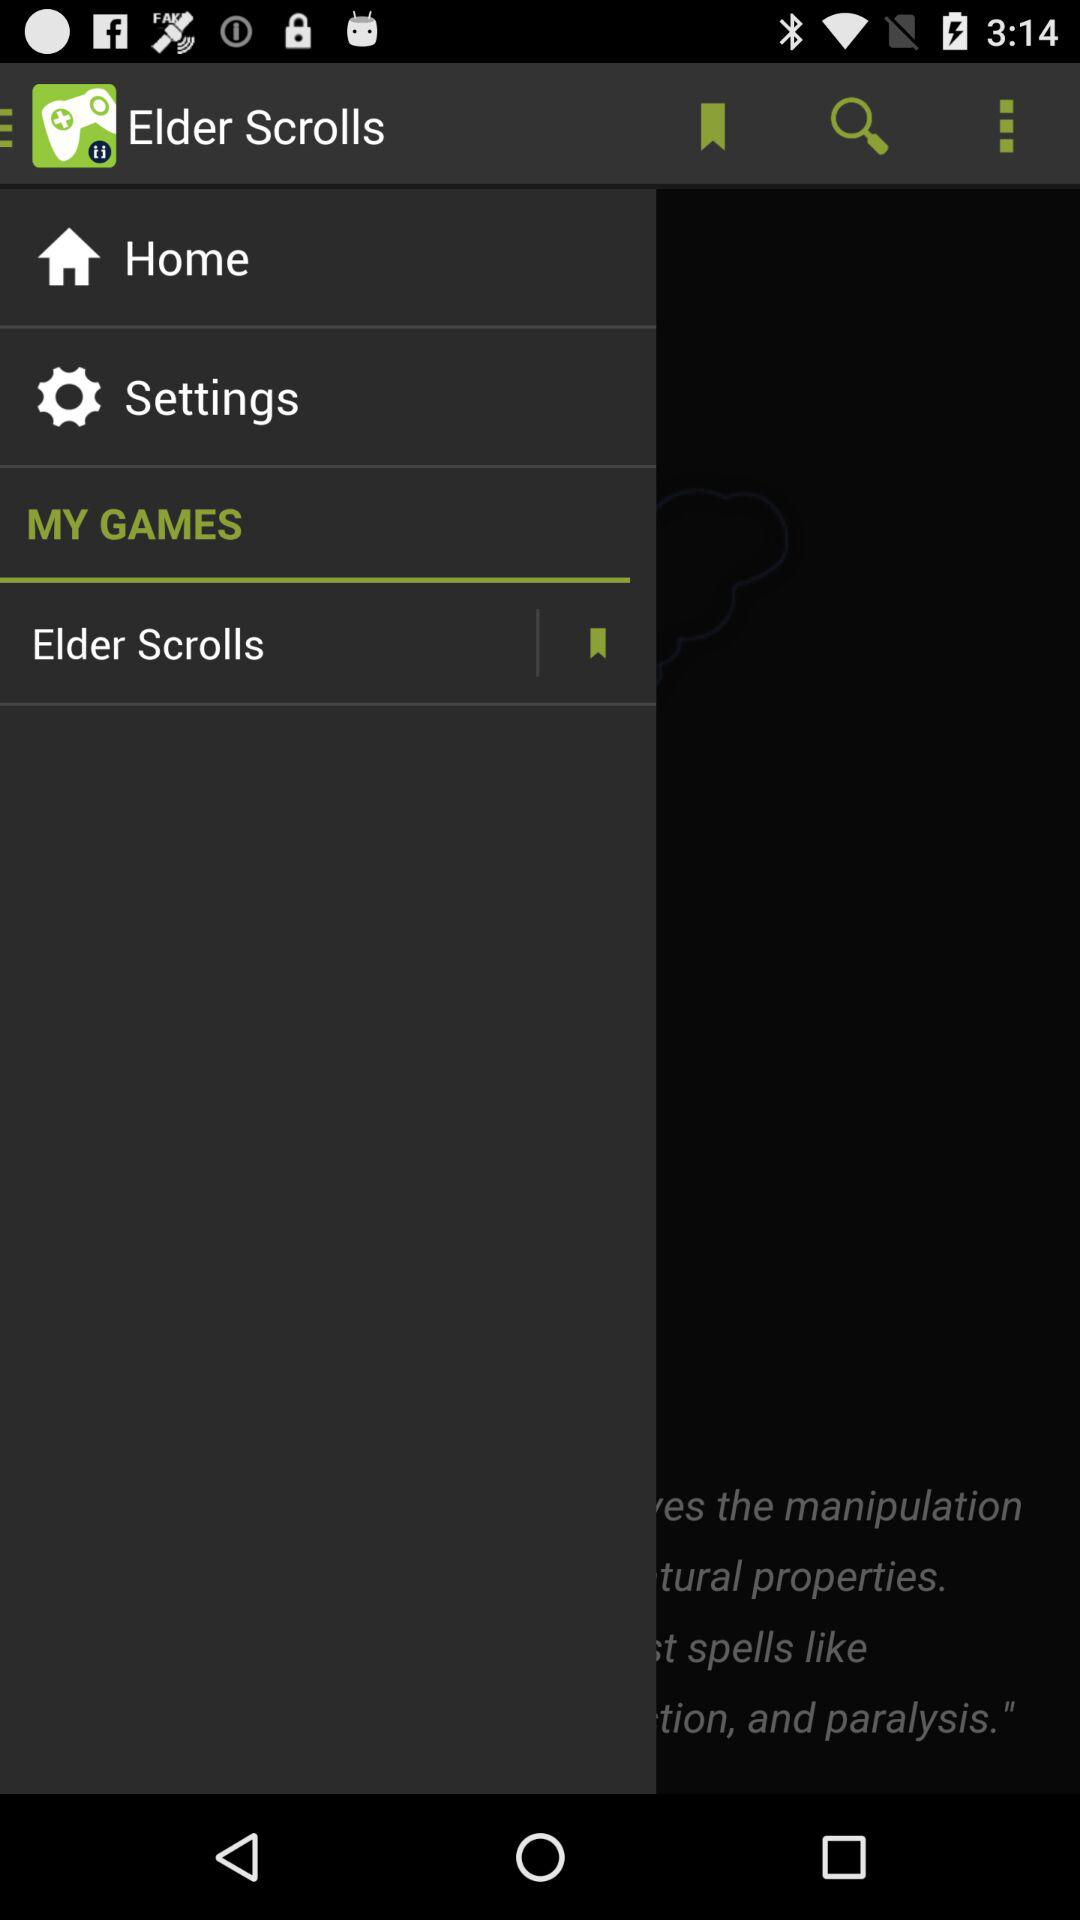What is the name of the application? The name of the application is "Elder Scrolls". 